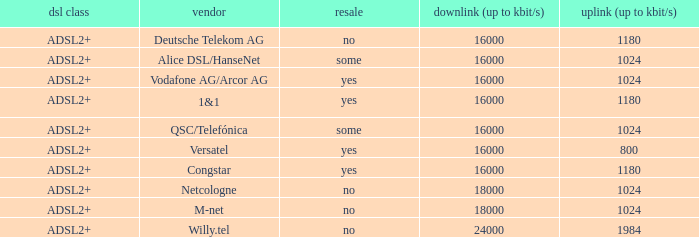Who are all of the telecom providers for which the upload rate is 1024 kbits and the resale category is yes? Vodafone AG/Arcor AG. 